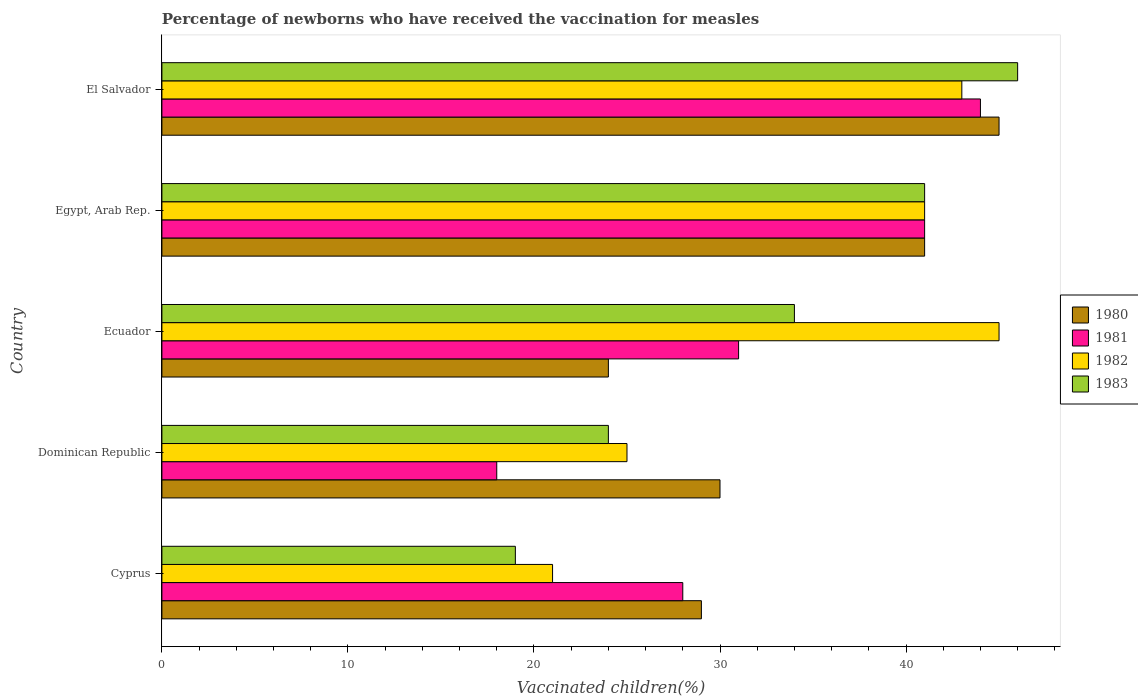How many different coloured bars are there?
Keep it short and to the point. 4. How many groups of bars are there?
Your answer should be compact. 5. Are the number of bars on each tick of the Y-axis equal?
Make the answer very short. Yes. How many bars are there on the 5th tick from the top?
Provide a succinct answer. 4. How many bars are there on the 1st tick from the bottom?
Give a very brief answer. 4. What is the label of the 2nd group of bars from the top?
Ensure brevity in your answer.  Egypt, Arab Rep. Across all countries, what is the maximum percentage of vaccinated children in 1983?
Provide a short and direct response. 46. In which country was the percentage of vaccinated children in 1980 maximum?
Provide a short and direct response. El Salvador. In which country was the percentage of vaccinated children in 1983 minimum?
Make the answer very short. Cyprus. What is the total percentage of vaccinated children in 1980 in the graph?
Keep it short and to the point. 169. What is the difference between the percentage of vaccinated children in 1980 in Dominican Republic and that in Egypt, Arab Rep.?
Offer a very short reply. -11. What is the average percentage of vaccinated children in 1983 per country?
Offer a terse response. 32.8. In how many countries, is the percentage of vaccinated children in 1980 greater than 16 %?
Your response must be concise. 5. What is the ratio of the percentage of vaccinated children in 1982 in Egypt, Arab Rep. to that in El Salvador?
Give a very brief answer. 0.95. In how many countries, is the percentage of vaccinated children in 1981 greater than the average percentage of vaccinated children in 1981 taken over all countries?
Offer a very short reply. 2. Is it the case that in every country, the sum of the percentage of vaccinated children in 1983 and percentage of vaccinated children in 1981 is greater than the percentage of vaccinated children in 1980?
Give a very brief answer. Yes. How many bars are there?
Ensure brevity in your answer.  20. What is the difference between two consecutive major ticks on the X-axis?
Keep it short and to the point. 10. Does the graph contain any zero values?
Keep it short and to the point. No. Does the graph contain grids?
Keep it short and to the point. No. How are the legend labels stacked?
Make the answer very short. Vertical. What is the title of the graph?
Provide a short and direct response. Percentage of newborns who have received the vaccination for measles. What is the label or title of the X-axis?
Make the answer very short. Vaccinated children(%). What is the Vaccinated children(%) of 1980 in Cyprus?
Give a very brief answer. 29. What is the Vaccinated children(%) in 1983 in Cyprus?
Offer a terse response. 19. What is the Vaccinated children(%) of 1980 in Dominican Republic?
Ensure brevity in your answer.  30. What is the Vaccinated children(%) in 1981 in Dominican Republic?
Offer a very short reply. 18. What is the Vaccinated children(%) of 1983 in Dominican Republic?
Your response must be concise. 24. What is the Vaccinated children(%) in 1981 in Ecuador?
Make the answer very short. 31. What is the Vaccinated children(%) in 1982 in Ecuador?
Your answer should be compact. 45. What is the Vaccinated children(%) of 1981 in Egypt, Arab Rep.?
Your answer should be compact. 41. What is the Vaccinated children(%) of 1982 in Egypt, Arab Rep.?
Make the answer very short. 41. What is the Vaccinated children(%) in 1983 in Egypt, Arab Rep.?
Ensure brevity in your answer.  41. What is the Vaccinated children(%) in 1981 in El Salvador?
Your answer should be compact. 44. What is the Vaccinated children(%) of 1982 in El Salvador?
Provide a succinct answer. 43. Across all countries, what is the maximum Vaccinated children(%) of 1980?
Your answer should be compact. 45. Across all countries, what is the maximum Vaccinated children(%) of 1981?
Ensure brevity in your answer.  44. Across all countries, what is the minimum Vaccinated children(%) in 1980?
Offer a very short reply. 24. Across all countries, what is the minimum Vaccinated children(%) of 1981?
Your answer should be compact. 18. Across all countries, what is the minimum Vaccinated children(%) in 1982?
Keep it short and to the point. 21. Across all countries, what is the minimum Vaccinated children(%) in 1983?
Your answer should be compact. 19. What is the total Vaccinated children(%) of 1980 in the graph?
Your answer should be very brief. 169. What is the total Vaccinated children(%) in 1981 in the graph?
Your answer should be very brief. 162. What is the total Vaccinated children(%) in 1982 in the graph?
Offer a very short reply. 175. What is the total Vaccinated children(%) of 1983 in the graph?
Your response must be concise. 164. What is the difference between the Vaccinated children(%) in 1980 in Cyprus and that in Ecuador?
Give a very brief answer. 5. What is the difference between the Vaccinated children(%) of 1981 in Cyprus and that in Ecuador?
Make the answer very short. -3. What is the difference between the Vaccinated children(%) in 1983 in Cyprus and that in Ecuador?
Offer a very short reply. -15. What is the difference between the Vaccinated children(%) of 1980 in Cyprus and that in Egypt, Arab Rep.?
Provide a succinct answer. -12. What is the difference between the Vaccinated children(%) of 1982 in Cyprus and that in Egypt, Arab Rep.?
Your answer should be very brief. -20. What is the difference between the Vaccinated children(%) of 1983 in Cyprus and that in Egypt, Arab Rep.?
Your answer should be compact. -22. What is the difference between the Vaccinated children(%) of 1981 in Cyprus and that in El Salvador?
Offer a very short reply. -16. What is the difference between the Vaccinated children(%) in 1980 in Dominican Republic and that in Ecuador?
Provide a succinct answer. 6. What is the difference between the Vaccinated children(%) of 1981 in Dominican Republic and that in Ecuador?
Make the answer very short. -13. What is the difference between the Vaccinated children(%) of 1982 in Dominican Republic and that in Ecuador?
Offer a very short reply. -20. What is the difference between the Vaccinated children(%) in 1983 in Dominican Republic and that in Ecuador?
Ensure brevity in your answer.  -10. What is the difference between the Vaccinated children(%) in 1980 in Dominican Republic and that in Egypt, Arab Rep.?
Make the answer very short. -11. What is the difference between the Vaccinated children(%) of 1981 in Dominican Republic and that in Egypt, Arab Rep.?
Give a very brief answer. -23. What is the difference between the Vaccinated children(%) of 1982 in Dominican Republic and that in Egypt, Arab Rep.?
Your answer should be very brief. -16. What is the difference between the Vaccinated children(%) of 1982 in Dominican Republic and that in El Salvador?
Make the answer very short. -18. What is the difference between the Vaccinated children(%) of 1981 in Ecuador and that in Egypt, Arab Rep.?
Make the answer very short. -10. What is the difference between the Vaccinated children(%) of 1981 in Ecuador and that in El Salvador?
Provide a succinct answer. -13. What is the difference between the Vaccinated children(%) of 1983 in Ecuador and that in El Salvador?
Your answer should be very brief. -12. What is the difference between the Vaccinated children(%) of 1982 in Egypt, Arab Rep. and that in El Salvador?
Provide a short and direct response. -2. What is the difference between the Vaccinated children(%) in 1980 in Cyprus and the Vaccinated children(%) in 1981 in Dominican Republic?
Your response must be concise. 11. What is the difference between the Vaccinated children(%) of 1980 in Cyprus and the Vaccinated children(%) of 1982 in Dominican Republic?
Your response must be concise. 4. What is the difference between the Vaccinated children(%) of 1980 in Cyprus and the Vaccinated children(%) of 1983 in Dominican Republic?
Offer a terse response. 5. What is the difference between the Vaccinated children(%) of 1981 in Cyprus and the Vaccinated children(%) of 1983 in Dominican Republic?
Make the answer very short. 4. What is the difference between the Vaccinated children(%) of 1982 in Cyprus and the Vaccinated children(%) of 1983 in Dominican Republic?
Offer a terse response. -3. What is the difference between the Vaccinated children(%) in 1980 in Cyprus and the Vaccinated children(%) in 1981 in Ecuador?
Keep it short and to the point. -2. What is the difference between the Vaccinated children(%) in 1980 in Cyprus and the Vaccinated children(%) in 1982 in Ecuador?
Provide a short and direct response. -16. What is the difference between the Vaccinated children(%) in 1980 in Cyprus and the Vaccinated children(%) in 1983 in Ecuador?
Your answer should be compact. -5. What is the difference between the Vaccinated children(%) of 1981 in Cyprus and the Vaccinated children(%) of 1982 in Ecuador?
Your answer should be compact. -17. What is the difference between the Vaccinated children(%) in 1981 in Cyprus and the Vaccinated children(%) in 1983 in Ecuador?
Your answer should be compact. -6. What is the difference between the Vaccinated children(%) of 1982 in Cyprus and the Vaccinated children(%) of 1983 in Ecuador?
Your answer should be compact. -13. What is the difference between the Vaccinated children(%) of 1981 in Cyprus and the Vaccinated children(%) of 1983 in Egypt, Arab Rep.?
Your answer should be compact. -13. What is the difference between the Vaccinated children(%) of 1980 in Cyprus and the Vaccinated children(%) of 1983 in El Salvador?
Keep it short and to the point. -17. What is the difference between the Vaccinated children(%) of 1981 in Cyprus and the Vaccinated children(%) of 1982 in El Salvador?
Your answer should be very brief. -15. What is the difference between the Vaccinated children(%) of 1980 in Dominican Republic and the Vaccinated children(%) of 1981 in Ecuador?
Make the answer very short. -1. What is the difference between the Vaccinated children(%) of 1981 in Dominican Republic and the Vaccinated children(%) of 1982 in Ecuador?
Your response must be concise. -27. What is the difference between the Vaccinated children(%) in 1981 in Dominican Republic and the Vaccinated children(%) in 1983 in Ecuador?
Keep it short and to the point. -16. What is the difference between the Vaccinated children(%) in 1980 in Dominican Republic and the Vaccinated children(%) in 1981 in Egypt, Arab Rep.?
Offer a terse response. -11. What is the difference between the Vaccinated children(%) in 1980 in Dominican Republic and the Vaccinated children(%) in 1983 in Egypt, Arab Rep.?
Your response must be concise. -11. What is the difference between the Vaccinated children(%) in 1981 in Dominican Republic and the Vaccinated children(%) in 1983 in Egypt, Arab Rep.?
Keep it short and to the point. -23. What is the difference between the Vaccinated children(%) of 1982 in Dominican Republic and the Vaccinated children(%) of 1983 in Egypt, Arab Rep.?
Provide a succinct answer. -16. What is the difference between the Vaccinated children(%) in 1980 in Dominican Republic and the Vaccinated children(%) in 1982 in El Salvador?
Ensure brevity in your answer.  -13. What is the difference between the Vaccinated children(%) of 1981 in Dominican Republic and the Vaccinated children(%) of 1983 in El Salvador?
Your response must be concise. -28. What is the difference between the Vaccinated children(%) in 1982 in Dominican Republic and the Vaccinated children(%) in 1983 in El Salvador?
Provide a succinct answer. -21. What is the difference between the Vaccinated children(%) of 1980 in Ecuador and the Vaccinated children(%) of 1981 in Egypt, Arab Rep.?
Your answer should be compact. -17. What is the difference between the Vaccinated children(%) in 1980 in Ecuador and the Vaccinated children(%) in 1982 in Egypt, Arab Rep.?
Give a very brief answer. -17. What is the difference between the Vaccinated children(%) of 1980 in Ecuador and the Vaccinated children(%) of 1982 in El Salvador?
Offer a very short reply. -19. What is the difference between the Vaccinated children(%) of 1981 in Ecuador and the Vaccinated children(%) of 1982 in El Salvador?
Provide a short and direct response. -12. What is the difference between the Vaccinated children(%) in 1980 in Egypt, Arab Rep. and the Vaccinated children(%) in 1982 in El Salvador?
Your answer should be compact. -2. What is the difference between the Vaccinated children(%) in 1981 in Egypt, Arab Rep. and the Vaccinated children(%) in 1982 in El Salvador?
Offer a terse response. -2. What is the average Vaccinated children(%) of 1980 per country?
Give a very brief answer. 33.8. What is the average Vaccinated children(%) of 1981 per country?
Keep it short and to the point. 32.4. What is the average Vaccinated children(%) in 1982 per country?
Your answer should be very brief. 35. What is the average Vaccinated children(%) of 1983 per country?
Your answer should be very brief. 32.8. What is the difference between the Vaccinated children(%) in 1980 and Vaccinated children(%) in 1981 in Cyprus?
Ensure brevity in your answer.  1. What is the difference between the Vaccinated children(%) of 1980 and Vaccinated children(%) of 1983 in Cyprus?
Ensure brevity in your answer.  10. What is the difference between the Vaccinated children(%) of 1982 and Vaccinated children(%) of 1983 in Cyprus?
Provide a succinct answer. 2. What is the difference between the Vaccinated children(%) in 1980 and Vaccinated children(%) in 1981 in Dominican Republic?
Make the answer very short. 12. What is the difference between the Vaccinated children(%) in 1980 and Vaccinated children(%) in 1982 in Dominican Republic?
Make the answer very short. 5. What is the difference between the Vaccinated children(%) of 1980 and Vaccinated children(%) of 1983 in Dominican Republic?
Give a very brief answer. 6. What is the difference between the Vaccinated children(%) in 1981 and Vaccinated children(%) in 1983 in Dominican Republic?
Ensure brevity in your answer.  -6. What is the difference between the Vaccinated children(%) in 1982 and Vaccinated children(%) in 1983 in Dominican Republic?
Offer a terse response. 1. What is the difference between the Vaccinated children(%) of 1980 and Vaccinated children(%) of 1981 in Ecuador?
Keep it short and to the point. -7. What is the difference between the Vaccinated children(%) in 1981 and Vaccinated children(%) in 1983 in Ecuador?
Your response must be concise. -3. What is the difference between the Vaccinated children(%) in 1982 and Vaccinated children(%) in 1983 in Ecuador?
Give a very brief answer. 11. What is the difference between the Vaccinated children(%) of 1980 and Vaccinated children(%) of 1982 in Egypt, Arab Rep.?
Your answer should be very brief. 0. What is the difference between the Vaccinated children(%) of 1980 and Vaccinated children(%) of 1983 in Egypt, Arab Rep.?
Ensure brevity in your answer.  0. What is the difference between the Vaccinated children(%) in 1981 and Vaccinated children(%) in 1983 in Egypt, Arab Rep.?
Your answer should be very brief. 0. What is the difference between the Vaccinated children(%) of 1980 and Vaccinated children(%) of 1981 in El Salvador?
Ensure brevity in your answer.  1. What is the difference between the Vaccinated children(%) in 1980 and Vaccinated children(%) in 1982 in El Salvador?
Ensure brevity in your answer.  2. What is the ratio of the Vaccinated children(%) of 1980 in Cyprus to that in Dominican Republic?
Give a very brief answer. 0.97. What is the ratio of the Vaccinated children(%) in 1981 in Cyprus to that in Dominican Republic?
Your response must be concise. 1.56. What is the ratio of the Vaccinated children(%) in 1982 in Cyprus to that in Dominican Republic?
Offer a terse response. 0.84. What is the ratio of the Vaccinated children(%) in 1983 in Cyprus to that in Dominican Republic?
Your answer should be compact. 0.79. What is the ratio of the Vaccinated children(%) of 1980 in Cyprus to that in Ecuador?
Offer a terse response. 1.21. What is the ratio of the Vaccinated children(%) of 1981 in Cyprus to that in Ecuador?
Give a very brief answer. 0.9. What is the ratio of the Vaccinated children(%) of 1982 in Cyprus to that in Ecuador?
Give a very brief answer. 0.47. What is the ratio of the Vaccinated children(%) of 1983 in Cyprus to that in Ecuador?
Ensure brevity in your answer.  0.56. What is the ratio of the Vaccinated children(%) in 1980 in Cyprus to that in Egypt, Arab Rep.?
Ensure brevity in your answer.  0.71. What is the ratio of the Vaccinated children(%) in 1981 in Cyprus to that in Egypt, Arab Rep.?
Ensure brevity in your answer.  0.68. What is the ratio of the Vaccinated children(%) in 1982 in Cyprus to that in Egypt, Arab Rep.?
Offer a very short reply. 0.51. What is the ratio of the Vaccinated children(%) of 1983 in Cyprus to that in Egypt, Arab Rep.?
Offer a terse response. 0.46. What is the ratio of the Vaccinated children(%) in 1980 in Cyprus to that in El Salvador?
Offer a very short reply. 0.64. What is the ratio of the Vaccinated children(%) in 1981 in Cyprus to that in El Salvador?
Offer a terse response. 0.64. What is the ratio of the Vaccinated children(%) in 1982 in Cyprus to that in El Salvador?
Provide a succinct answer. 0.49. What is the ratio of the Vaccinated children(%) of 1983 in Cyprus to that in El Salvador?
Offer a terse response. 0.41. What is the ratio of the Vaccinated children(%) in 1980 in Dominican Republic to that in Ecuador?
Ensure brevity in your answer.  1.25. What is the ratio of the Vaccinated children(%) in 1981 in Dominican Republic to that in Ecuador?
Keep it short and to the point. 0.58. What is the ratio of the Vaccinated children(%) of 1982 in Dominican Republic to that in Ecuador?
Make the answer very short. 0.56. What is the ratio of the Vaccinated children(%) in 1983 in Dominican Republic to that in Ecuador?
Offer a terse response. 0.71. What is the ratio of the Vaccinated children(%) of 1980 in Dominican Republic to that in Egypt, Arab Rep.?
Keep it short and to the point. 0.73. What is the ratio of the Vaccinated children(%) in 1981 in Dominican Republic to that in Egypt, Arab Rep.?
Your answer should be very brief. 0.44. What is the ratio of the Vaccinated children(%) in 1982 in Dominican Republic to that in Egypt, Arab Rep.?
Provide a short and direct response. 0.61. What is the ratio of the Vaccinated children(%) in 1983 in Dominican Republic to that in Egypt, Arab Rep.?
Provide a short and direct response. 0.59. What is the ratio of the Vaccinated children(%) of 1980 in Dominican Republic to that in El Salvador?
Keep it short and to the point. 0.67. What is the ratio of the Vaccinated children(%) in 1981 in Dominican Republic to that in El Salvador?
Ensure brevity in your answer.  0.41. What is the ratio of the Vaccinated children(%) in 1982 in Dominican Republic to that in El Salvador?
Keep it short and to the point. 0.58. What is the ratio of the Vaccinated children(%) in 1983 in Dominican Republic to that in El Salvador?
Offer a very short reply. 0.52. What is the ratio of the Vaccinated children(%) in 1980 in Ecuador to that in Egypt, Arab Rep.?
Provide a short and direct response. 0.59. What is the ratio of the Vaccinated children(%) in 1981 in Ecuador to that in Egypt, Arab Rep.?
Provide a short and direct response. 0.76. What is the ratio of the Vaccinated children(%) of 1982 in Ecuador to that in Egypt, Arab Rep.?
Offer a terse response. 1.1. What is the ratio of the Vaccinated children(%) in 1983 in Ecuador to that in Egypt, Arab Rep.?
Offer a terse response. 0.83. What is the ratio of the Vaccinated children(%) of 1980 in Ecuador to that in El Salvador?
Ensure brevity in your answer.  0.53. What is the ratio of the Vaccinated children(%) of 1981 in Ecuador to that in El Salvador?
Your answer should be very brief. 0.7. What is the ratio of the Vaccinated children(%) of 1982 in Ecuador to that in El Salvador?
Offer a very short reply. 1.05. What is the ratio of the Vaccinated children(%) in 1983 in Ecuador to that in El Salvador?
Provide a short and direct response. 0.74. What is the ratio of the Vaccinated children(%) of 1980 in Egypt, Arab Rep. to that in El Salvador?
Your answer should be very brief. 0.91. What is the ratio of the Vaccinated children(%) in 1981 in Egypt, Arab Rep. to that in El Salvador?
Offer a very short reply. 0.93. What is the ratio of the Vaccinated children(%) in 1982 in Egypt, Arab Rep. to that in El Salvador?
Offer a very short reply. 0.95. What is the ratio of the Vaccinated children(%) of 1983 in Egypt, Arab Rep. to that in El Salvador?
Offer a terse response. 0.89. What is the difference between the highest and the second highest Vaccinated children(%) in 1981?
Offer a terse response. 3. What is the difference between the highest and the second highest Vaccinated children(%) of 1982?
Make the answer very short. 2. What is the difference between the highest and the lowest Vaccinated children(%) of 1981?
Give a very brief answer. 26. What is the difference between the highest and the lowest Vaccinated children(%) of 1982?
Keep it short and to the point. 24. What is the difference between the highest and the lowest Vaccinated children(%) of 1983?
Your answer should be compact. 27. 